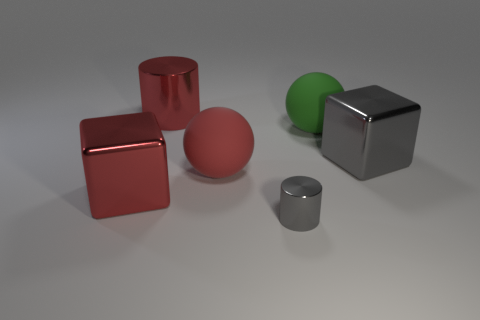Is there any other thing that has the same material as the big gray cube?
Offer a terse response. Yes. Is there a gray object that is in front of the big metal object that is right of the cylinder that is in front of the red cylinder?
Ensure brevity in your answer.  Yes. What material is the large object right of the green thing?
Make the answer very short. Metal. What number of big objects are gray metal cylinders or red shiny objects?
Make the answer very short. 2. There is a matte object that is left of the gray metal cylinder; is it the same size as the gray cube?
Provide a short and direct response. Yes. How many other objects are there of the same color as the large cylinder?
Keep it short and to the point. 2. What material is the big red block?
Your response must be concise. Metal. The object that is both right of the red rubber ball and in front of the gray metallic block is made of what material?
Keep it short and to the point. Metal. What number of objects are blocks right of the red cylinder or big metallic things?
Ensure brevity in your answer.  3. Are there any red metallic cylinders that have the same size as the red ball?
Your answer should be compact. Yes. 